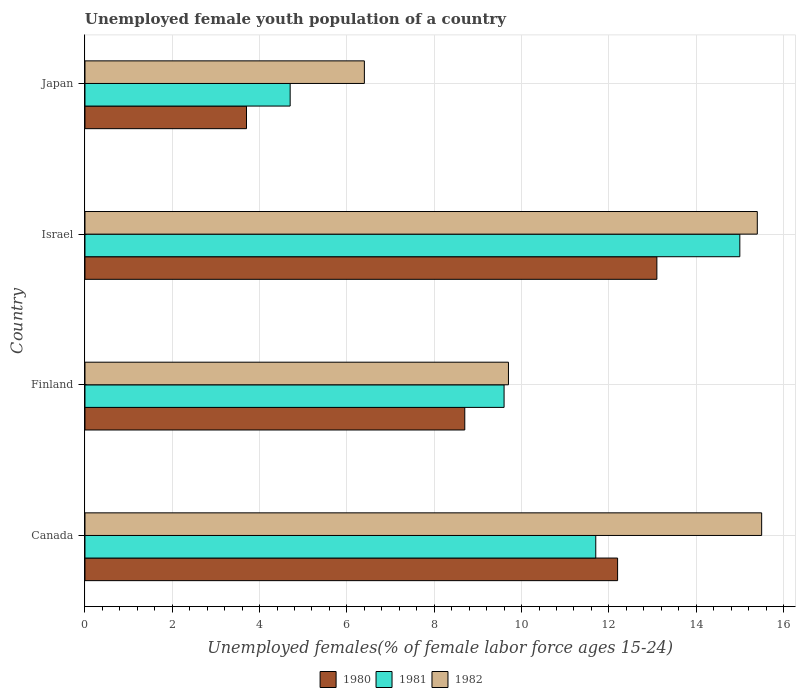Are the number of bars per tick equal to the number of legend labels?
Your answer should be compact. Yes. In how many cases, is the number of bars for a given country not equal to the number of legend labels?
Make the answer very short. 0. What is the percentage of unemployed female youth population in 1981 in Canada?
Provide a short and direct response. 11.7. Across all countries, what is the maximum percentage of unemployed female youth population in 1980?
Provide a short and direct response. 13.1. Across all countries, what is the minimum percentage of unemployed female youth population in 1981?
Your answer should be compact. 4.7. In which country was the percentage of unemployed female youth population in 1982 maximum?
Keep it short and to the point. Canada. In which country was the percentage of unemployed female youth population in 1982 minimum?
Keep it short and to the point. Japan. What is the total percentage of unemployed female youth population in 1981 in the graph?
Your response must be concise. 41. What is the difference between the percentage of unemployed female youth population in 1980 in Finland and that in Israel?
Give a very brief answer. -4.4. What is the difference between the percentage of unemployed female youth population in 1982 in Japan and the percentage of unemployed female youth population in 1981 in Finland?
Your response must be concise. -3.2. What is the average percentage of unemployed female youth population in 1981 per country?
Your response must be concise. 10.25. In how many countries, is the percentage of unemployed female youth population in 1982 greater than 8.8 %?
Your answer should be very brief. 3. What is the ratio of the percentage of unemployed female youth population in 1981 in Finland to that in Israel?
Your answer should be very brief. 0.64. Is the percentage of unemployed female youth population in 1980 in Canada less than that in Israel?
Your response must be concise. Yes. Is the difference between the percentage of unemployed female youth population in 1980 in Canada and Finland greater than the difference between the percentage of unemployed female youth population in 1981 in Canada and Finland?
Offer a terse response. Yes. What is the difference between the highest and the second highest percentage of unemployed female youth population in 1982?
Offer a terse response. 0.1. What is the difference between the highest and the lowest percentage of unemployed female youth population in 1982?
Offer a very short reply. 9.1. Is the sum of the percentage of unemployed female youth population in 1982 in Canada and Israel greater than the maximum percentage of unemployed female youth population in 1980 across all countries?
Keep it short and to the point. Yes. What is the difference between two consecutive major ticks on the X-axis?
Your response must be concise. 2. Are the values on the major ticks of X-axis written in scientific E-notation?
Offer a terse response. No. Does the graph contain grids?
Ensure brevity in your answer.  Yes. Where does the legend appear in the graph?
Your answer should be compact. Bottom center. What is the title of the graph?
Your answer should be compact. Unemployed female youth population of a country. What is the label or title of the X-axis?
Keep it short and to the point. Unemployed females(% of female labor force ages 15-24). What is the Unemployed females(% of female labor force ages 15-24) of 1980 in Canada?
Ensure brevity in your answer.  12.2. What is the Unemployed females(% of female labor force ages 15-24) in 1981 in Canada?
Make the answer very short. 11.7. What is the Unemployed females(% of female labor force ages 15-24) of 1982 in Canada?
Your answer should be compact. 15.5. What is the Unemployed females(% of female labor force ages 15-24) of 1980 in Finland?
Your answer should be very brief. 8.7. What is the Unemployed females(% of female labor force ages 15-24) in 1981 in Finland?
Ensure brevity in your answer.  9.6. What is the Unemployed females(% of female labor force ages 15-24) in 1982 in Finland?
Offer a very short reply. 9.7. What is the Unemployed females(% of female labor force ages 15-24) in 1980 in Israel?
Ensure brevity in your answer.  13.1. What is the Unemployed females(% of female labor force ages 15-24) of 1981 in Israel?
Your answer should be very brief. 15. What is the Unemployed females(% of female labor force ages 15-24) of 1982 in Israel?
Your response must be concise. 15.4. What is the Unemployed females(% of female labor force ages 15-24) of 1980 in Japan?
Give a very brief answer. 3.7. What is the Unemployed females(% of female labor force ages 15-24) of 1981 in Japan?
Your answer should be compact. 4.7. What is the Unemployed females(% of female labor force ages 15-24) in 1982 in Japan?
Keep it short and to the point. 6.4. Across all countries, what is the maximum Unemployed females(% of female labor force ages 15-24) of 1980?
Make the answer very short. 13.1. Across all countries, what is the minimum Unemployed females(% of female labor force ages 15-24) in 1980?
Keep it short and to the point. 3.7. Across all countries, what is the minimum Unemployed females(% of female labor force ages 15-24) of 1981?
Keep it short and to the point. 4.7. Across all countries, what is the minimum Unemployed females(% of female labor force ages 15-24) of 1982?
Give a very brief answer. 6.4. What is the total Unemployed females(% of female labor force ages 15-24) of 1980 in the graph?
Your response must be concise. 37.7. What is the total Unemployed females(% of female labor force ages 15-24) in 1982 in the graph?
Provide a succinct answer. 47. What is the difference between the Unemployed females(% of female labor force ages 15-24) of 1981 in Canada and that in Finland?
Offer a terse response. 2.1. What is the difference between the Unemployed females(% of female labor force ages 15-24) in 1980 in Canada and that in Israel?
Your response must be concise. -0.9. What is the difference between the Unemployed females(% of female labor force ages 15-24) of 1982 in Canada and that in Israel?
Your response must be concise. 0.1. What is the difference between the Unemployed females(% of female labor force ages 15-24) of 1980 in Canada and that in Japan?
Give a very brief answer. 8.5. What is the difference between the Unemployed females(% of female labor force ages 15-24) in 1981 in Canada and that in Japan?
Provide a succinct answer. 7. What is the difference between the Unemployed females(% of female labor force ages 15-24) of 1982 in Canada and that in Japan?
Offer a very short reply. 9.1. What is the difference between the Unemployed females(% of female labor force ages 15-24) of 1982 in Finland and that in Israel?
Provide a succinct answer. -5.7. What is the difference between the Unemployed females(% of female labor force ages 15-24) of 1980 in Finland and that in Japan?
Your response must be concise. 5. What is the difference between the Unemployed females(% of female labor force ages 15-24) of 1982 in Finland and that in Japan?
Give a very brief answer. 3.3. What is the difference between the Unemployed females(% of female labor force ages 15-24) in 1982 in Israel and that in Japan?
Your answer should be compact. 9. What is the difference between the Unemployed females(% of female labor force ages 15-24) in 1980 in Canada and the Unemployed females(% of female labor force ages 15-24) in 1982 in Finland?
Give a very brief answer. 2.5. What is the difference between the Unemployed females(% of female labor force ages 15-24) of 1981 in Canada and the Unemployed females(% of female labor force ages 15-24) of 1982 in Finland?
Your response must be concise. 2. What is the difference between the Unemployed females(% of female labor force ages 15-24) of 1981 in Canada and the Unemployed females(% of female labor force ages 15-24) of 1982 in Japan?
Provide a succinct answer. 5.3. What is the difference between the Unemployed females(% of female labor force ages 15-24) of 1980 in Finland and the Unemployed females(% of female labor force ages 15-24) of 1981 in Israel?
Give a very brief answer. -6.3. What is the difference between the Unemployed females(% of female labor force ages 15-24) of 1980 in Finland and the Unemployed females(% of female labor force ages 15-24) of 1982 in Israel?
Keep it short and to the point. -6.7. What is the difference between the Unemployed females(% of female labor force ages 15-24) in 1981 in Finland and the Unemployed females(% of female labor force ages 15-24) in 1982 in Israel?
Provide a succinct answer. -5.8. What is the difference between the Unemployed females(% of female labor force ages 15-24) in 1980 in Israel and the Unemployed females(% of female labor force ages 15-24) in 1981 in Japan?
Your answer should be compact. 8.4. What is the difference between the Unemployed females(% of female labor force ages 15-24) of 1980 in Israel and the Unemployed females(% of female labor force ages 15-24) of 1982 in Japan?
Offer a very short reply. 6.7. What is the average Unemployed females(% of female labor force ages 15-24) in 1980 per country?
Provide a short and direct response. 9.43. What is the average Unemployed females(% of female labor force ages 15-24) in 1981 per country?
Your response must be concise. 10.25. What is the average Unemployed females(% of female labor force ages 15-24) in 1982 per country?
Offer a very short reply. 11.75. What is the difference between the Unemployed females(% of female labor force ages 15-24) of 1980 and Unemployed females(% of female labor force ages 15-24) of 1982 in Canada?
Provide a short and direct response. -3.3. What is the difference between the Unemployed females(% of female labor force ages 15-24) of 1980 and Unemployed females(% of female labor force ages 15-24) of 1981 in Finland?
Keep it short and to the point. -0.9. What is the difference between the Unemployed females(% of female labor force ages 15-24) of 1981 and Unemployed females(% of female labor force ages 15-24) of 1982 in Finland?
Offer a terse response. -0.1. What is the difference between the Unemployed females(% of female labor force ages 15-24) of 1980 and Unemployed females(% of female labor force ages 15-24) of 1982 in Israel?
Offer a very short reply. -2.3. What is the difference between the Unemployed females(% of female labor force ages 15-24) in 1980 and Unemployed females(% of female labor force ages 15-24) in 1981 in Japan?
Provide a short and direct response. -1. What is the ratio of the Unemployed females(% of female labor force ages 15-24) in 1980 in Canada to that in Finland?
Provide a succinct answer. 1.4. What is the ratio of the Unemployed females(% of female labor force ages 15-24) in 1981 in Canada to that in Finland?
Ensure brevity in your answer.  1.22. What is the ratio of the Unemployed females(% of female labor force ages 15-24) of 1982 in Canada to that in Finland?
Make the answer very short. 1.6. What is the ratio of the Unemployed females(% of female labor force ages 15-24) in 1980 in Canada to that in Israel?
Keep it short and to the point. 0.93. What is the ratio of the Unemployed females(% of female labor force ages 15-24) in 1981 in Canada to that in Israel?
Keep it short and to the point. 0.78. What is the ratio of the Unemployed females(% of female labor force ages 15-24) of 1982 in Canada to that in Israel?
Make the answer very short. 1.01. What is the ratio of the Unemployed females(% of female labor force ages 15-24) of 1980 in Canada to that in Japan?
Your response must be concise. 3.3. What is the ratio of the Unemployed females(% of female labor force ages 15-24) of 1981 in Canada to that in Japan?
Offer a very short reply. 2.49. What is the ratio of the Unemployed females(% of female labor force ages 15-24) in 1982 in Canada to that in Japan?
Keep it short and to the point. 2.42. What is the ratio of the Unemployed females(% of female labor force ages 15-24) in 1980 in Finland to that in Israel?
Your answer should be compact. 0.66. What is the ratio of the Unemployed females(% of female labor force ages 15-24) of 1981 in Finland to that in Israel?
Offer a terse response. 0.64. What is the ratio of the Unemployed females(% of female labor force ages 15-24) of 1982 in Finland to that in Israel?
Your response must be concise. 0.63. What is the ratio of the Unemployed females(% of female labor force ages 15-24) of 1980 in Finland to that in Japan?
Your response must be concise. 2.35. What is the ratio of the Unemployed females(% of female labor force ages 15-24) in 1981 in Finland to that in Japan?
Your answer should be very brief. 2.04. What is the ratio of the Unemployed females(% of female labor force ages 15-24) in 1982 in Finland to that in Japan?
Your answer should be very brief. 1.52. What is the ratio of the Unemployed females(% of female labor force ages 15-24) of 1980 in Israel to that in Japan?
Provide a short and direct response. 3.54. What is the ratio of the Unemployed females(% of female labor force ages 15-24) in 1981 in Israel to that in Japan?
Offer a terse response. 3.19. What is the ratio of the Unemployed females(% of female labor force ages 15-24) of 1982 in Israel to that in Japan?
Your response must be concise. 2.41. What is the difference between the highest and the second highest Unemployed females(% of female labor force ages 15-24) of 1982?
Provide a short and direct response. 0.1. What is the difference between the highest and the lowest Unemployed females(% of female labor force ages 15-24) of 1982?
Your response must be concise. 9.1. 